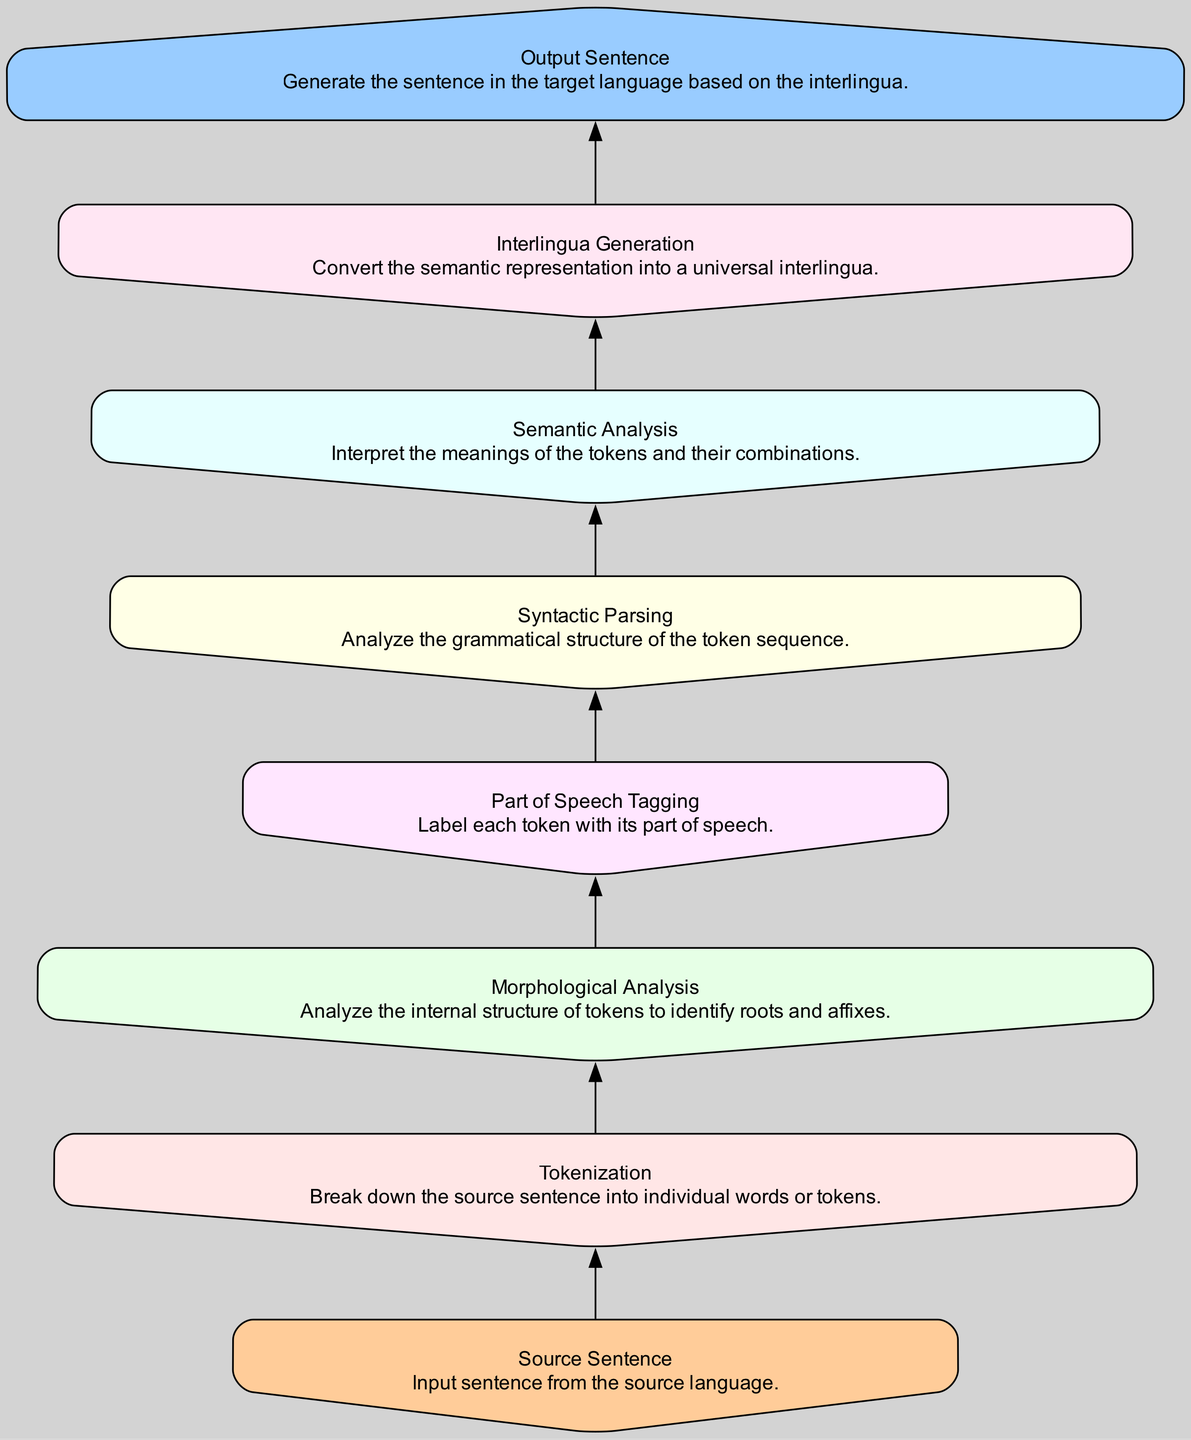What is the first step shown in the diagram? The first step in the flow chart is "Source Sentence," which indicates it is the starting point of the process where the input sentence is provided.
Answer: Source Sentence How many nodes are in the flow chart? By counting all the distinct steps in the flow chart from "Source Sentence" to "Output Sentence," there are a total of 8 nodes.
Answer: 8 What does the node "Semantic Analysis" represent? The "Semantic Analysis" node represents the step where the meanings of the tokens and their combinations are interpreted.
Answer: Interpret meanings What is the last step in the process? The last step in the flow chart is "Output Sentence," which generates the final sentence in the target language based on the interlingua.
Answer: Output Sentence Which node follows "Part of Speech Tagging"? Following "Part of Speech Tagging" in the flow chart is "Syntactic Parsing," which is the next step in the process.
Answer: Syntactic Parsing What type of analysis is done before "Interlingua Generation"? Before "Interlingua Generation," the type of analysis performed is "Semantic Analysis," which is crucial for understanding the sentence meaning.
Answer: Semantic Analysis How does one node lead to the next in this diagram? Each node is connected by directed edges that indicate the sequence in which the steps need to be performed, leading from one analysis step to the next.
Answer: Directed edges What is the purpose of "Morphological Analysis"? The purpose of "Morphological Analysis" is to analyze the internal structure of tokens, identifying their roots and affixes.
Answer: Identify roots and affixes 